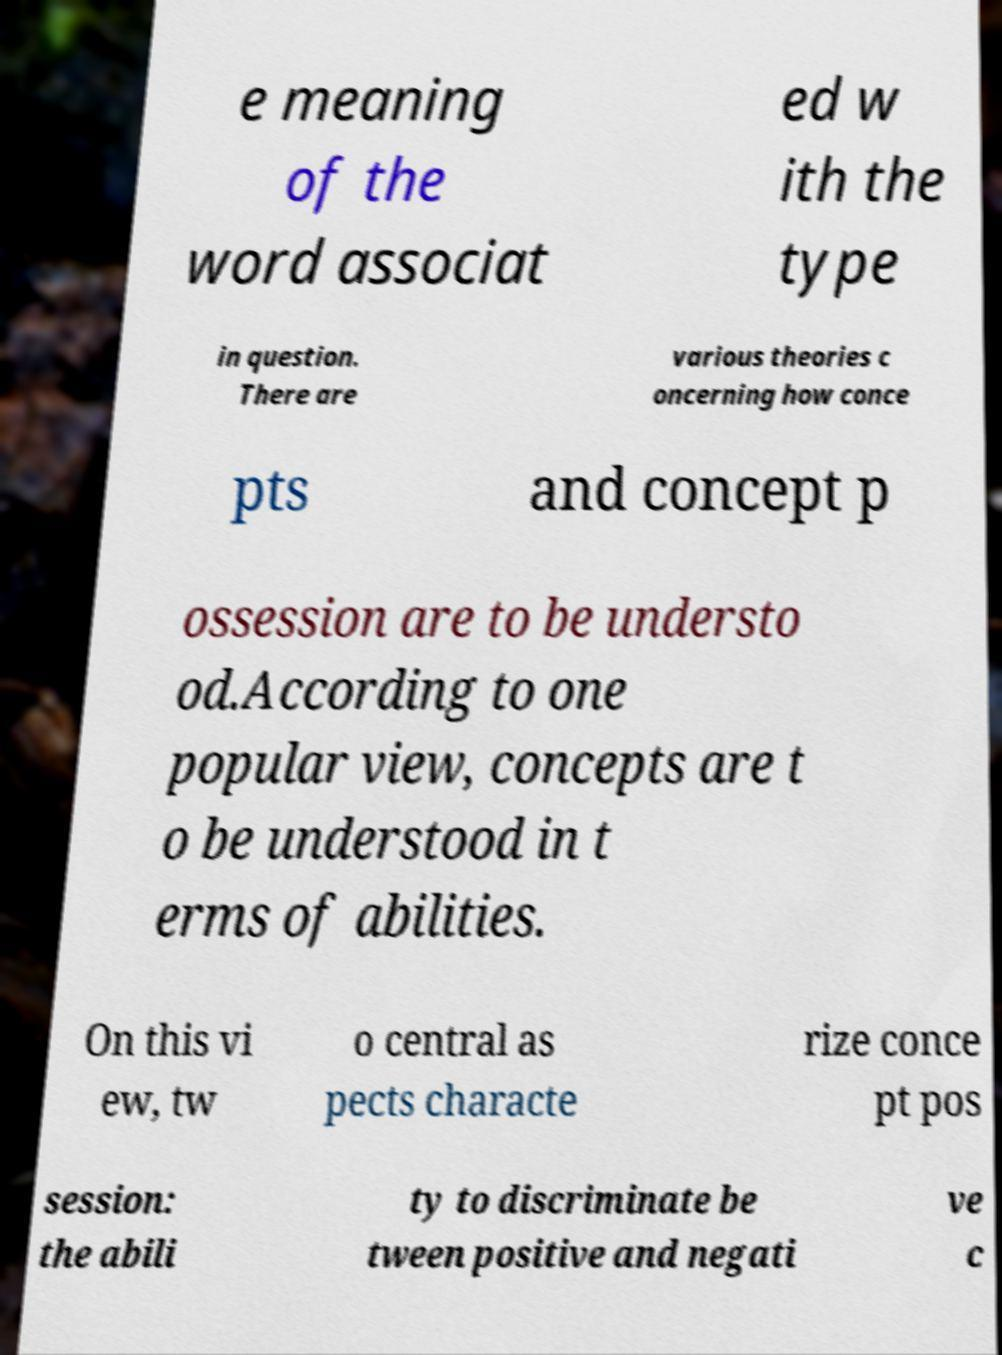Please identify and transcribe the text found in this image. e meaning of the word associat ed w ith the type in question. There are various theories c oncerning how conce pts and concept p ossession are to be understo od.According to one popular view, concepts are t o be understood in t erms of abilities. On this vi ew, tw o central as pects characte rize conce pt pos session: the abili ty to discriminate be tween positive and negati ve c 